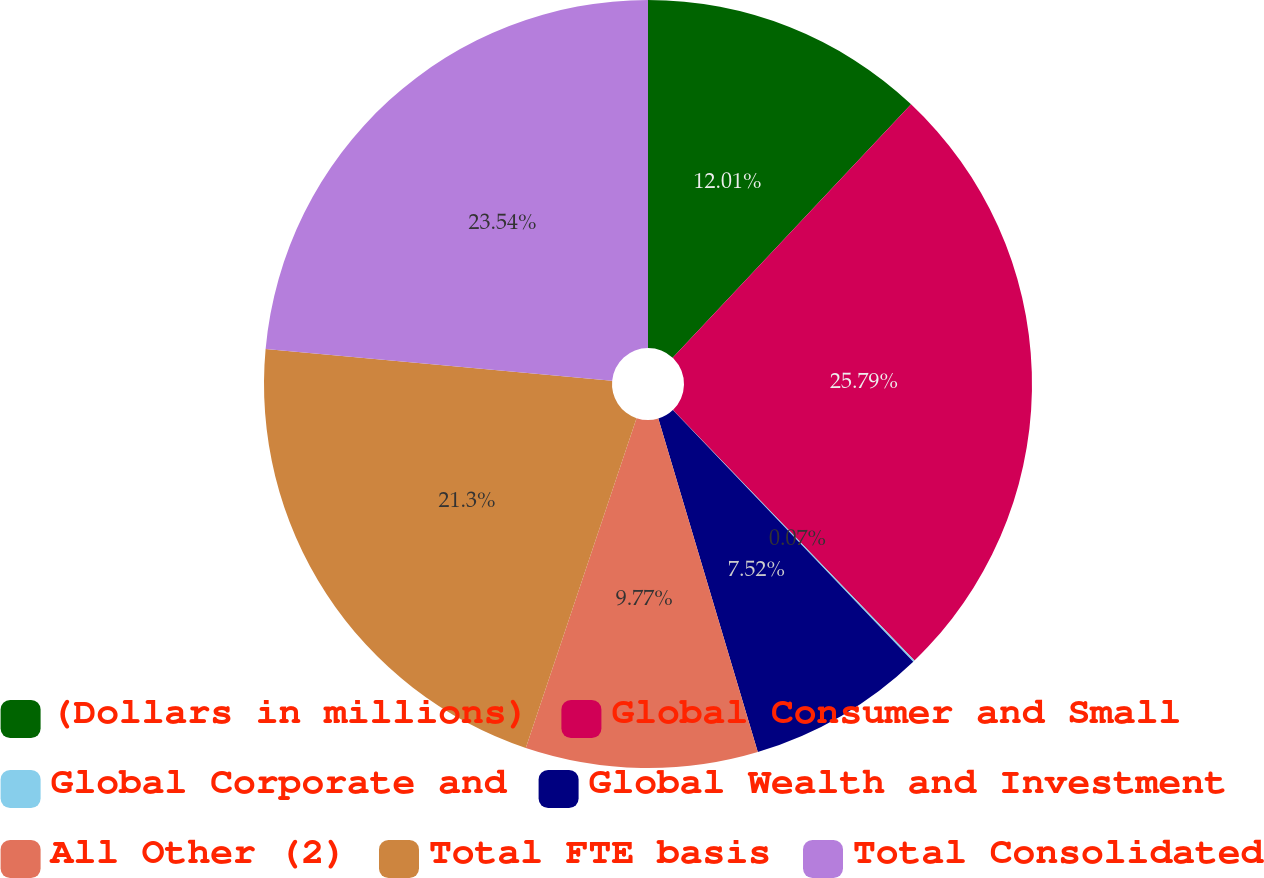Convert chart to OTSL. <chart><loc_0><loc_0><loc_500><loc_500><pie_chart><fcel>(Dollars in millions)<fcel>Global Consumer and Small<fcel>Global Corporate and<fcel>Global Wealth and Investment<fcel>All Other (2)<fcel>Total FTE basis<fcel>Total Consolidated<nl><fcel>12.01%<fcel>25.78%<fcel>0.07%<fcel>7.52%<fcel>9.77%<fcel>21.3%<fcel>23.54%<nl></chart> 